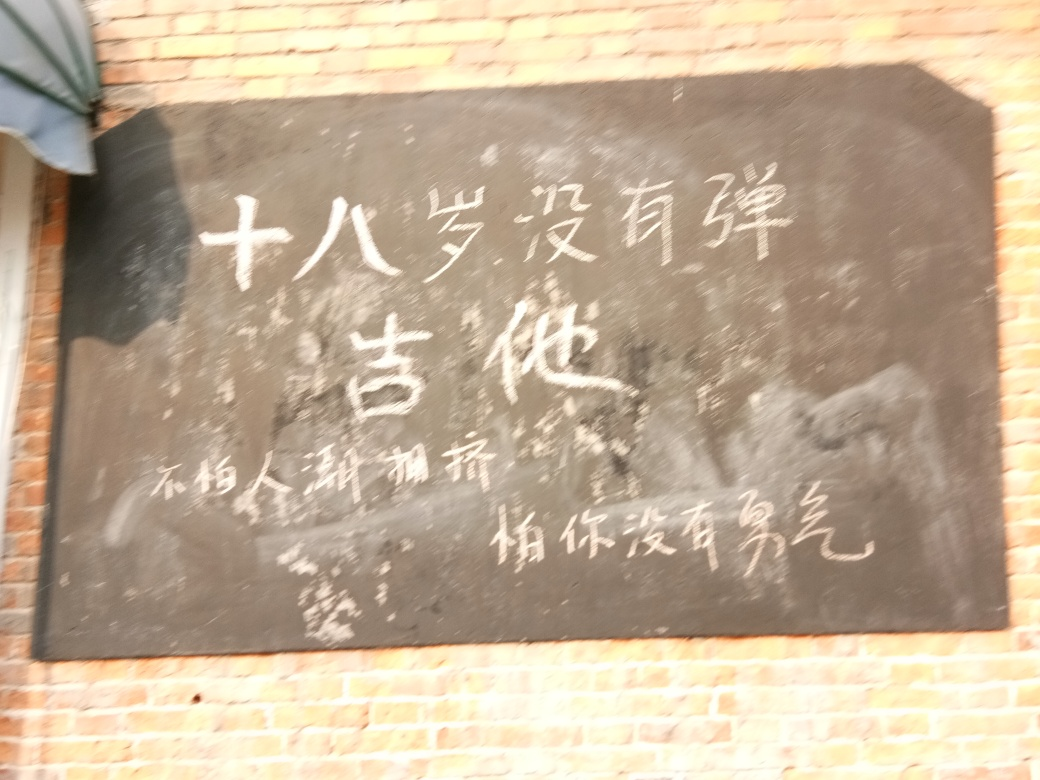What could be the significance of the text on the blackboard? If the blurriness were not an issue, the text may reveal information such as an educational lesson, a menu in a cafe, or an announcement. The specific characters, if legible, could also provide cultural insights or indicate the type of establishment or context in which the blackboard is used. 